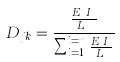Convert formula to latex. <formula><loc_0><loc_0><loc_500><loc_500>D _ { j k } = \frac { \frac { E _ { k } I _ { k } } { L _ { k } } } { \sum _ { i = 1 } ^ { i = n } \frac { E _ { i } I _ { i } } { L _ { i } } }</formula> 